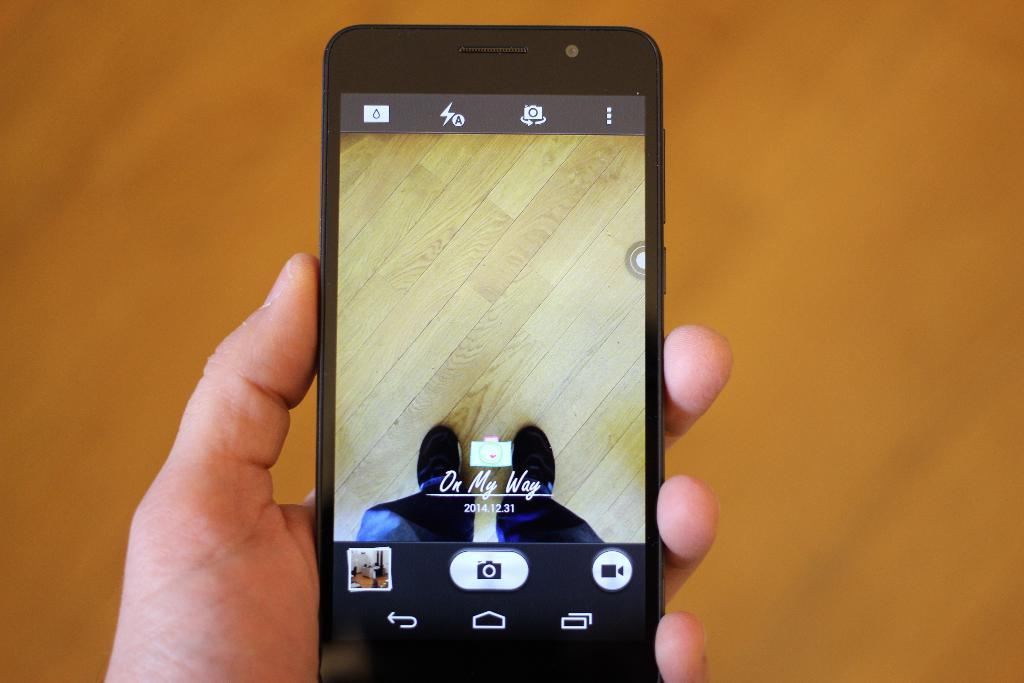<image>
Create a compact narrative representing the image presented. Person holding a black phone that says "on my way". 